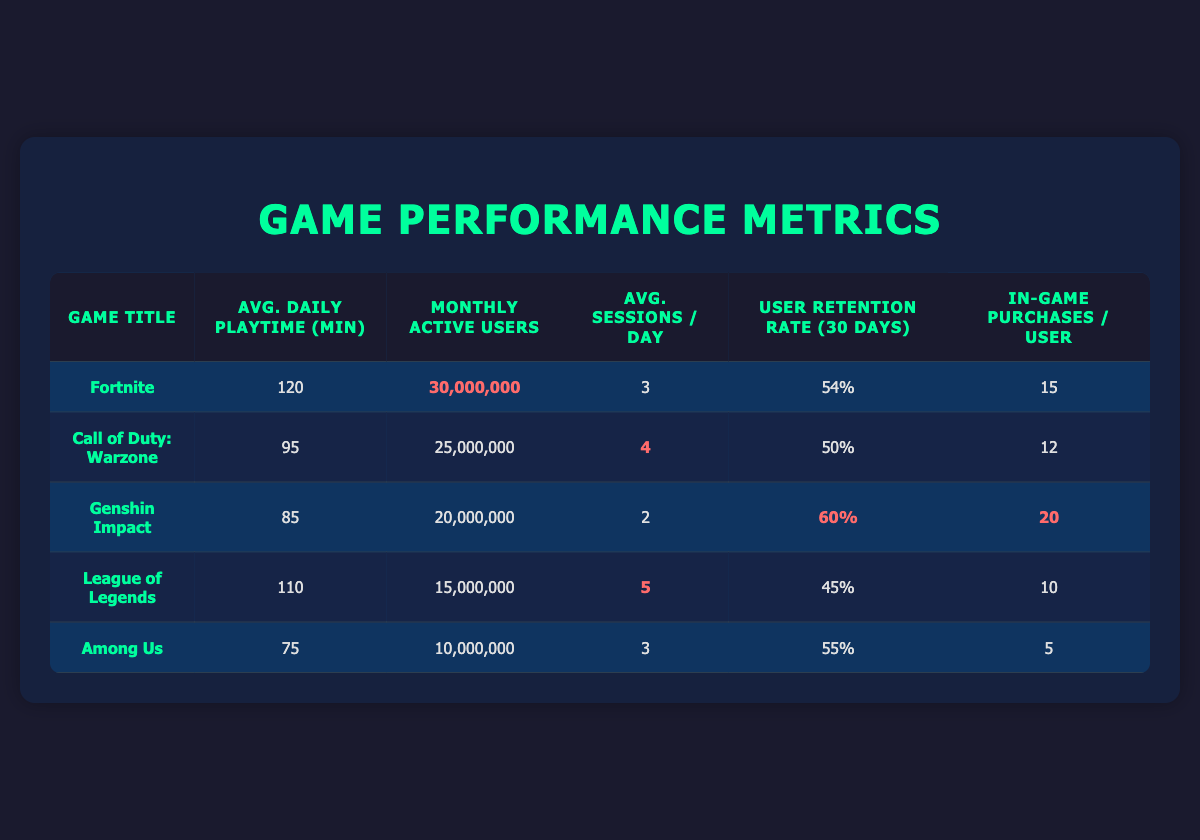What is the game title with the highest average daily playtime? By inspecting the "Avg. Daily Playtime (min)" column, I see that Fortnite has the highest value of 120 minutes compared to the other games.
Answer: Fortnite How many monthly active users does Genshin Impact have? Looking at the "Monthly Active Users" column for Genshin Impact, it has 20,000,000 users.
Answer: 20,000,000 Which game has the lowest user retention rate over 30 days? Checking the "User Retention Rate (30 days)" column, League of Legends has the lowest percentage at 45%.
Answer: League of Legends What is the average number of in-game purchases per user across all games? To find the average, I sum up the in-game purchases per user: 15 + 12 + 20 + 10 + 5 = 72. Then, I divide by the number of games, which is 5: 72 / 5 = 14.4.
Answer: 14.4 True or False: Among Us has more average sessions per day than Genshin Impact. Among Us has 3 sessions per day and Genshin Impact has 2, therefore, Among Us has more sessions.
Answer: True Which two games have a higher average daily playtime than the average of their peers? First, I calculate the average daily playtime: (120 + 95 + 85 + 110 + 75) / 5 = 97. The games exceeding this average are Fortnite (120) and League of Legends (110).
Answer: Fortnite and League of Legends How many in-game purchases per user does Call of Duty: Warzone have compared to Fortnite? Call of Duty has 12 in-game purchases per user, while Fortnite has 15. Since 12 is less than 15, it indicates that Call of Duty players, on average, purchase less.
Answer: 12 What is the average sessions per day for the games listed? To find this, I sum the average sessions: 3 + 4 + 2 + 5 + 3 = 17. Then, I divide by 5 to get the average: 17 / 5 = 3.4.
Answer: 3.4 How many games have a user retention rate of more than 50%? By examining the "User Retention Rate (30 days)" column, both Fortnite (54%) and Genshin Impact (60%) exceed 50%, making a total of 2 games.
Answer: 2 